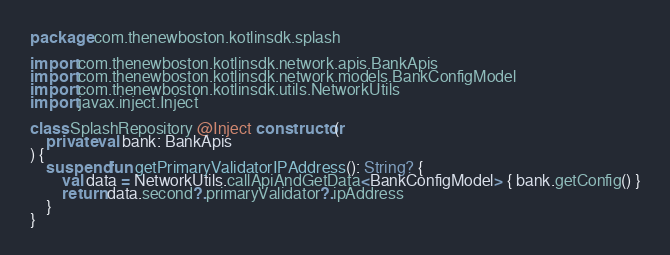Convert code to text. <code><loc_0><loc_0><loc_500><loc_500><_Kotlin_>package com.thenewboston.kotlinsdk.splash

import com.thenewboston.kotlinsdk.network.apis.BankApis
import com.thenewboston.kotlinsdk.network.models.BankConfigModel
import com.thenewboston.kotlinsdk.utils.NetworkUtils
import javax.inject.Inject

class SplashRepository @Inject constructor(
    private val bank: BankApis
) {
    suspend fun getPrimaryValidatorIPAddress(): String? {
        val data = NetworkUtils.callApiAndGetData<BankConfigModel> { bank.getConfig() }
        return data.second?.primaryValidator?.ipAddress
    }
}
</code> 